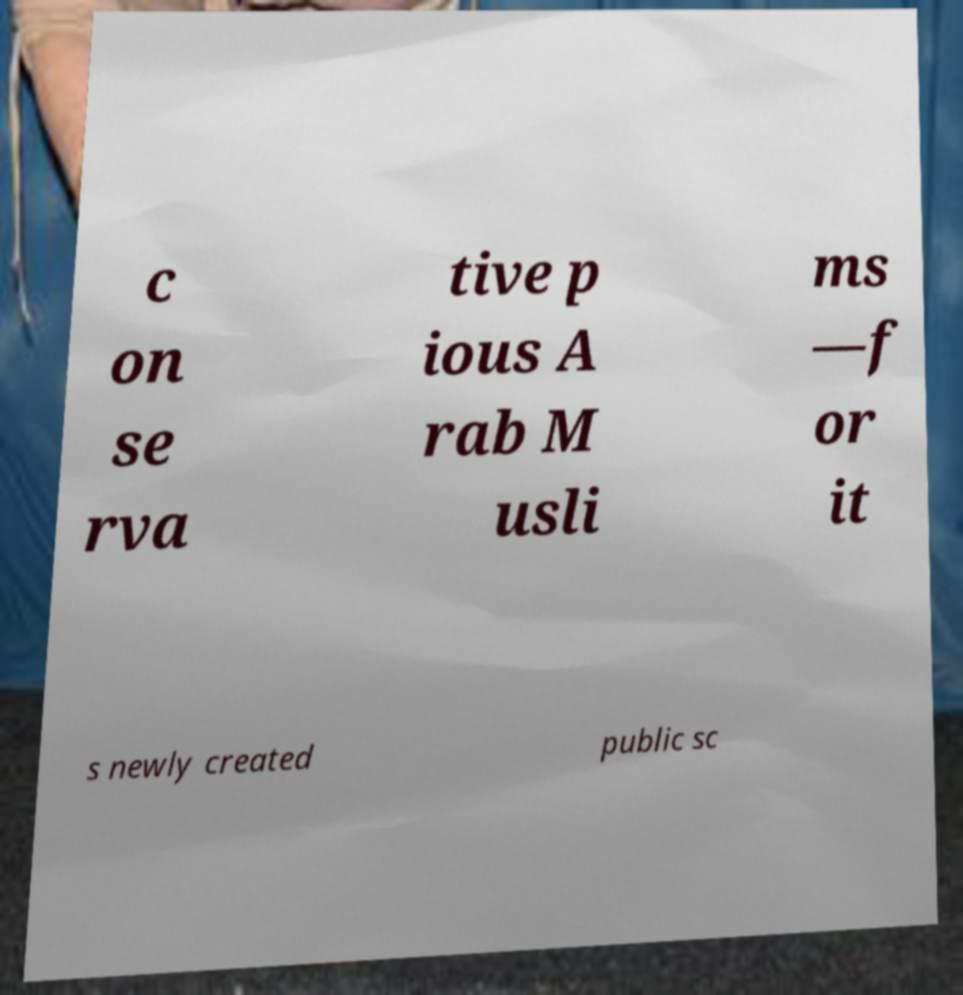Can you read and provide the text displayed in the image?This photo seems to have some interesting text. Can you extract and type it out for me? c on se rva tive p ious A rab M usli ms —f or it s newly created public sc 